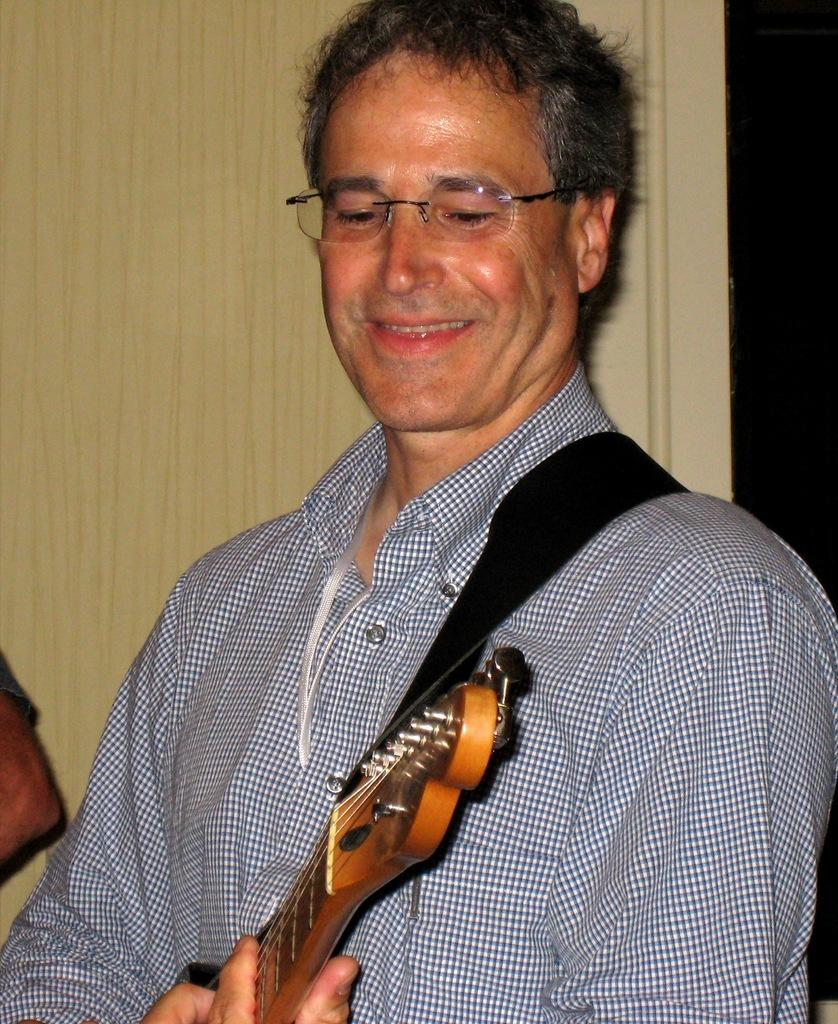What is the man in the image holding? The man is holding a guitar. What is the man's facial expression in the image? The man is smiling. What can be seen in the background of the image? There is a wooden wall in the background of the image. What type of map can be seen on the guitar in the image? There is no map present on the guitar in the image. What is the sun's position in the image? The provided facts do not mention the sun, so its position cannot be determined from the image. 